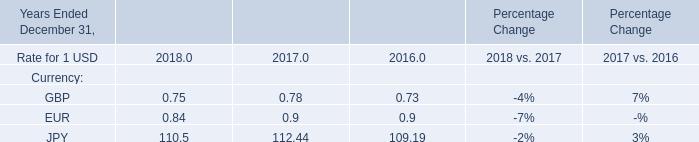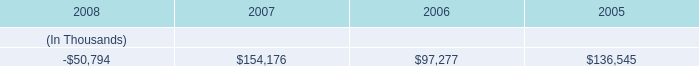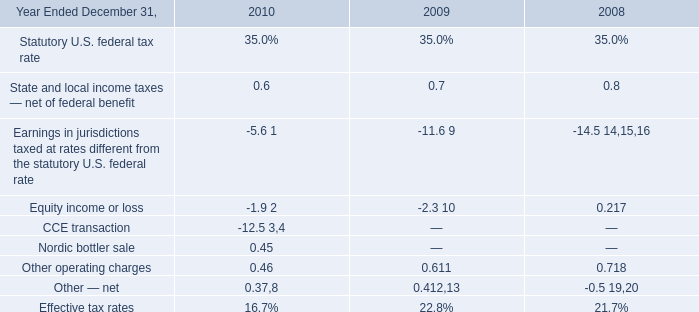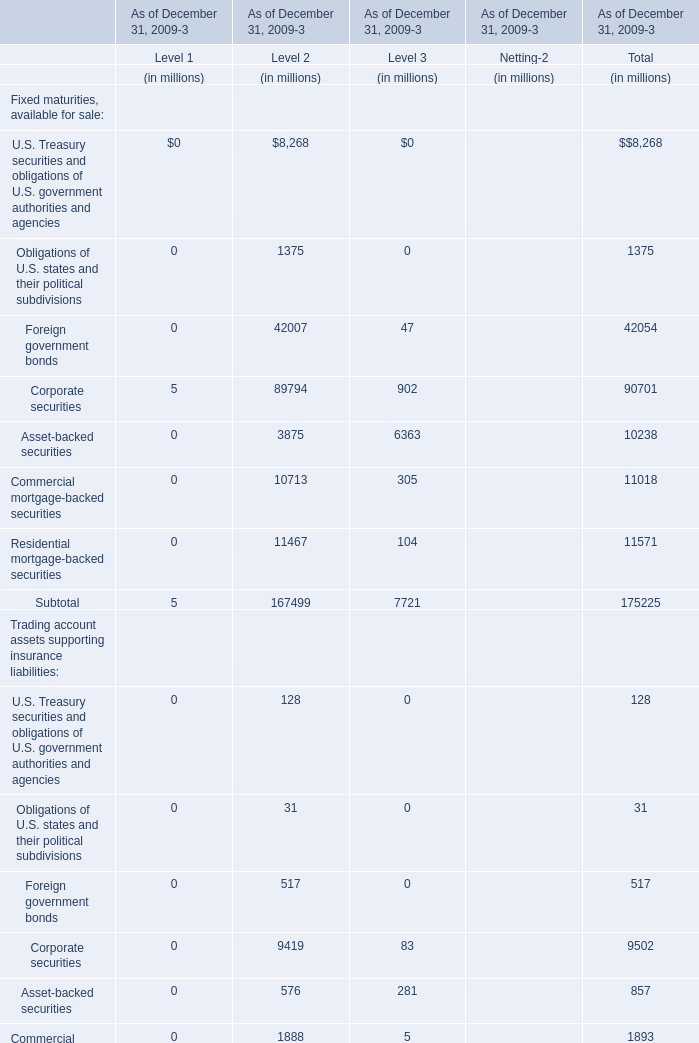what portion of the proceeds from the series mortgage bonds issued in january 2009 were used to repay the note payable to entergy corporation? 
Computations: (160 / 500)
Answer: 0.32. 